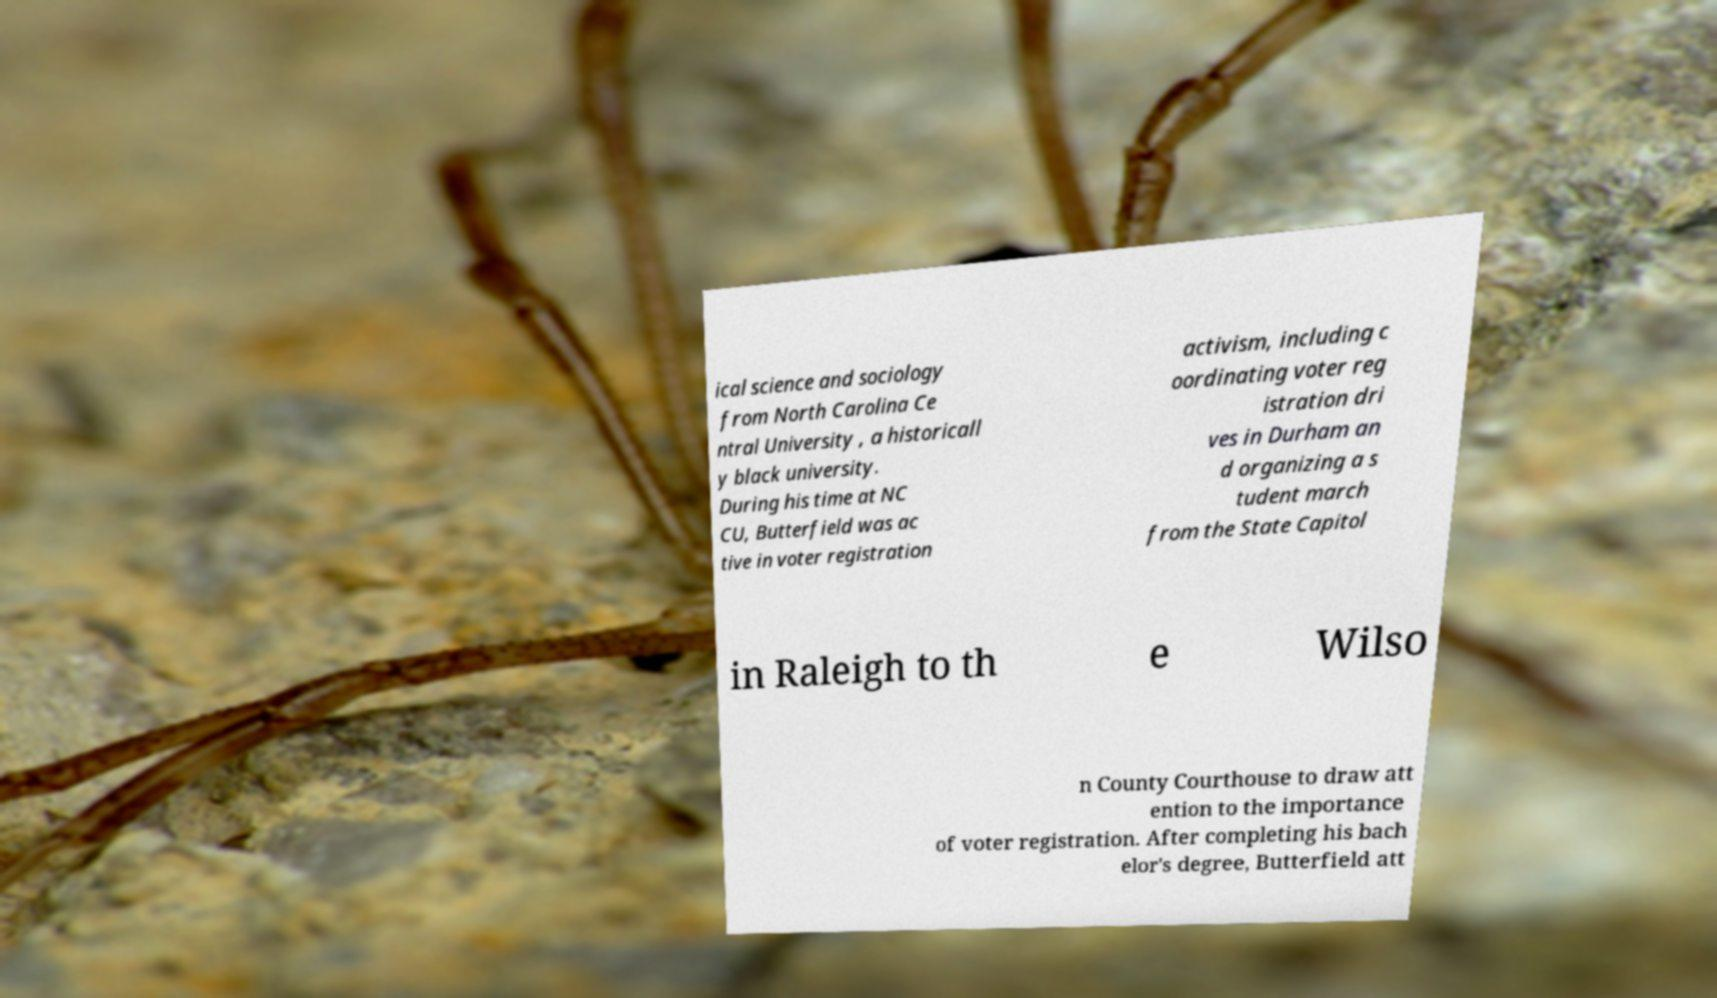I need the written content from this picture converted into text. Can you do that? ical science and sociology from North Carolina Ce ntral University , a historicall y black university. During his time at NC CU, Butterfield was ac tive in voter registration activism, including c oordinating voter reg istration dri ves in Durham an d organizing a s tudent march from the State Capitol in Raleigh to th e Wilso n County Courthouse to draw att ention to the importance of voter registration. After completing his bach elor's degree, Butterfield att 